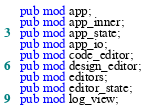Convert code to text. <code><loc_0><loc_0><loc_500><loc_500><_Rust_>pub mod app;
pub mod app_inner;
pub mod app_state;
pub mod app_io;
pub mod code_editor;
pub mod design_editor;
pub mod editors;
pub mod editor_state;
pub mod log_view;
</code> 